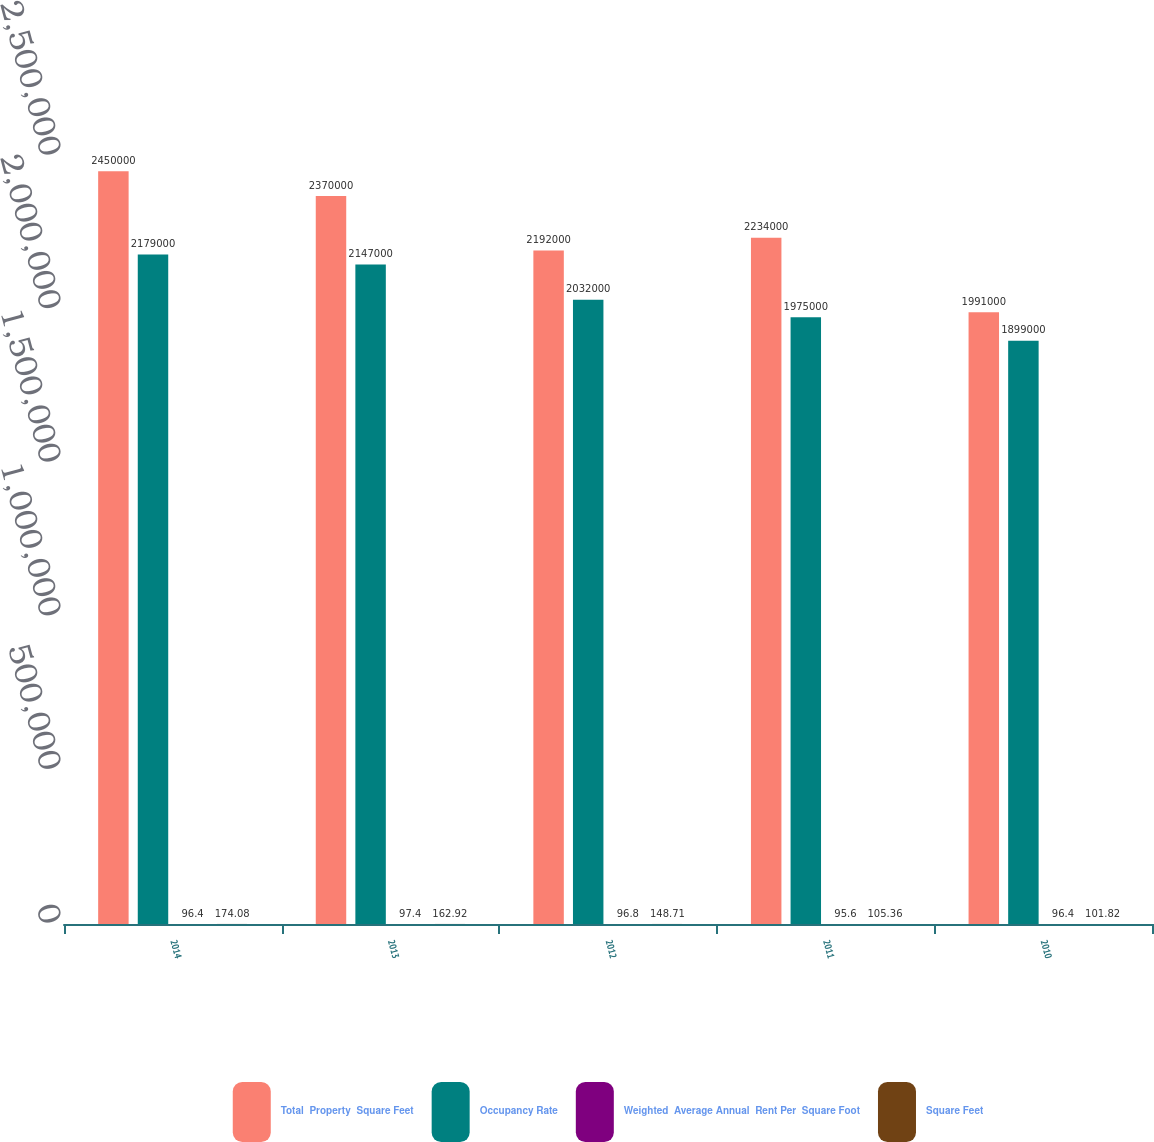Convert chart. <chart><loc_0><loc_0><loc_500><loc_500><stacked_bar_chart><ecel><fcel>2014<fcel>2013<fcel>2012<fcel>2011<fcel>2010<nl><fcel>Total  Property  Square Feet<fcel>2.45e+06<fcel>2.37e+06<fcel>2.192e+06<fcel>2.234e+06<fcel>1.991e+06<nl><fcel>Occupancy Rate<fcel>2.179e+06<fcel>2.147e+06<fcel>2.032e+06<fcel>1.975e+06<fcel>1.899e+06<nl><fcel>Weighted  Average Annual  Rent Per  Square Foot<fcel>96.4<fcel>97.4<fcel>96.8<fcel>95.6<fcel>96.4<nl><fcel>Square Feet<fcel>174.08<fcel>162.92<fcel>148.71<fcel>105.36<fcel>101.82<nl></chart> 